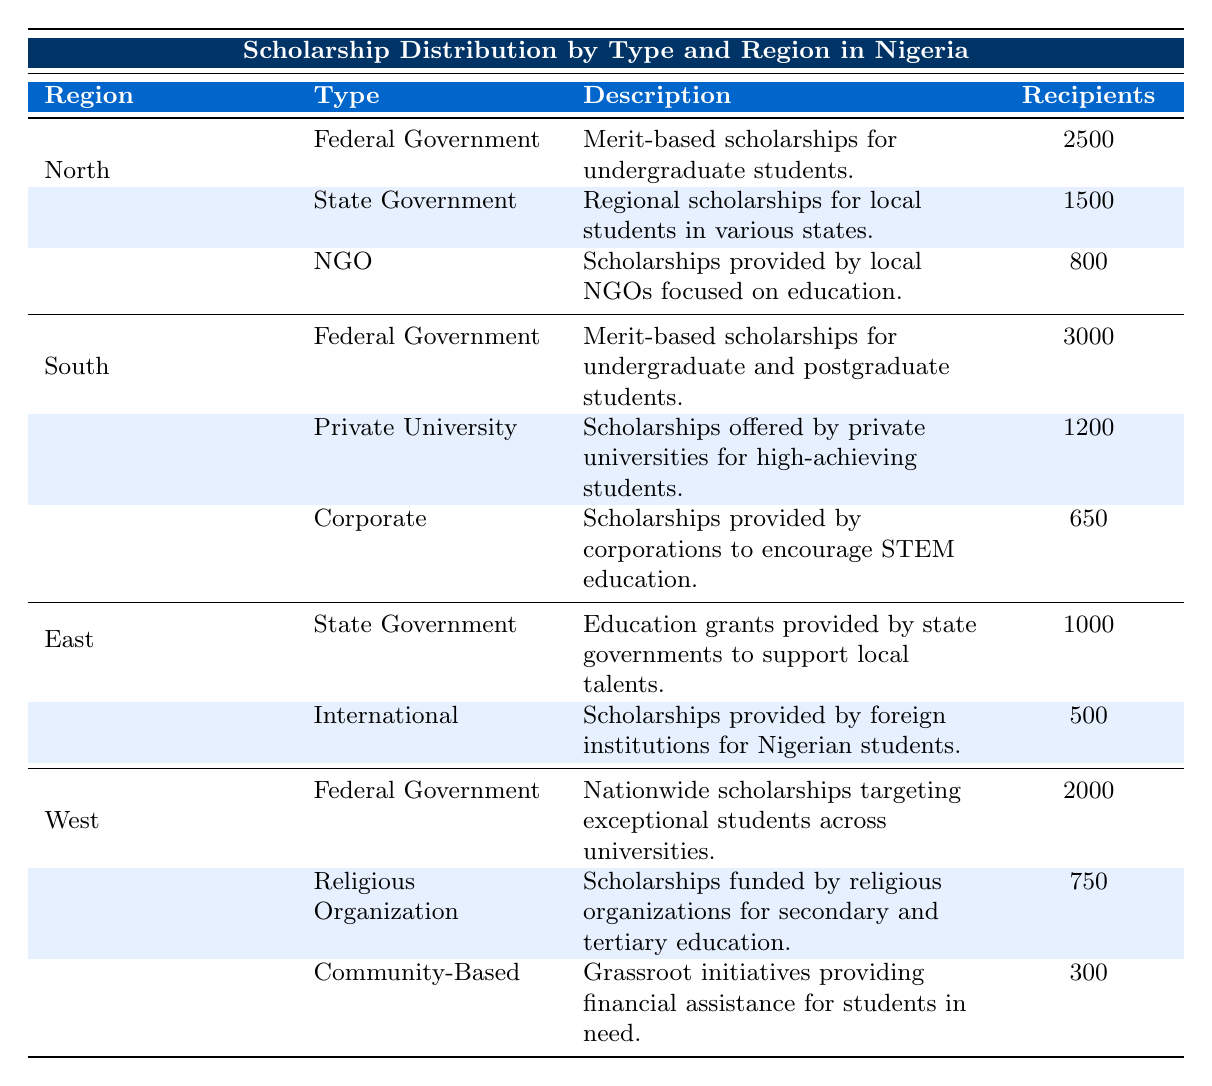What is the total number of recipients for scholarships in the North region? To find the total number of recipients in the North region, I will add up all the recipients for each scholarship type: 2500 (Federal Government) + 1500 (State Government) + 800 (NGO) = 4800.
Answer: 4800 Which type of scholarship has the highest number of recipients in the South region? Looking at the South region, the Federal Government Scholarships have the highest recipients with 3000, compared to 1200 (Private University) and 650 (Corporate).
Answer: Federal Government Scholarships Is the number of recipients for State Government Scholarships in the East region greater or less than that in the North region? In the East region, there are 1000 recipients for State Government Scholarships, while in the North region, there are 1500 recipients. Comparing these two numbers shows that 1000 is less than 1500.
Answer: Less How many more recipients does the South region have than the East region? To find the answer, I will first calculate the total number of recipients in both regions. In the South: 3000 (Federal Government) + 1200 (Private University) + 650 (Corporate) = 4850. In the East: 1000 (State Government) + 500 (International) = 1500. Now, subtract East from South: 4850 - 1500 = 3350.
Answer: 3350 Are there any scholarships in the West region funded by religious organizations? Yes, the table indicates the presence of Religious Organization Scholarships in the West region, which has 750 recipients.
Answer: Yes What is the average number of recipients for scholarships in the West region? In the West region, the total number of recipients is 2000 (Federal Government) + 750 (Religious Organization) + 300 (Community-Based) = 3050. There are 3 types of scholarships, so the average is 3050 / 3 = 1016.67.
Answer: 1016.67 Which region has the least number of different types of scholarships? By examining the table, the East region has only 2 types of scholarships listed (State Government and International), while the other regions have at least 3. Therefore, the East region has the least distinct types of scholarships.
Answer: East What is the total number of recipients for all scholarships listed in the table? To calculate the total number of recipients across all regions, I will sum all the numbers: 4800 (North) + 4850 (South) + 1500 (East) + 3050 (West) = 13700.
Answer: 13700 Which type of scholarship has the least number of recipients in the South region? In the South region, the Corporate Scholarships have the least recipients with 650, compared to 1200 (Private University) and 3000 (Federal Government).
Answer: Corporate Scholarships 